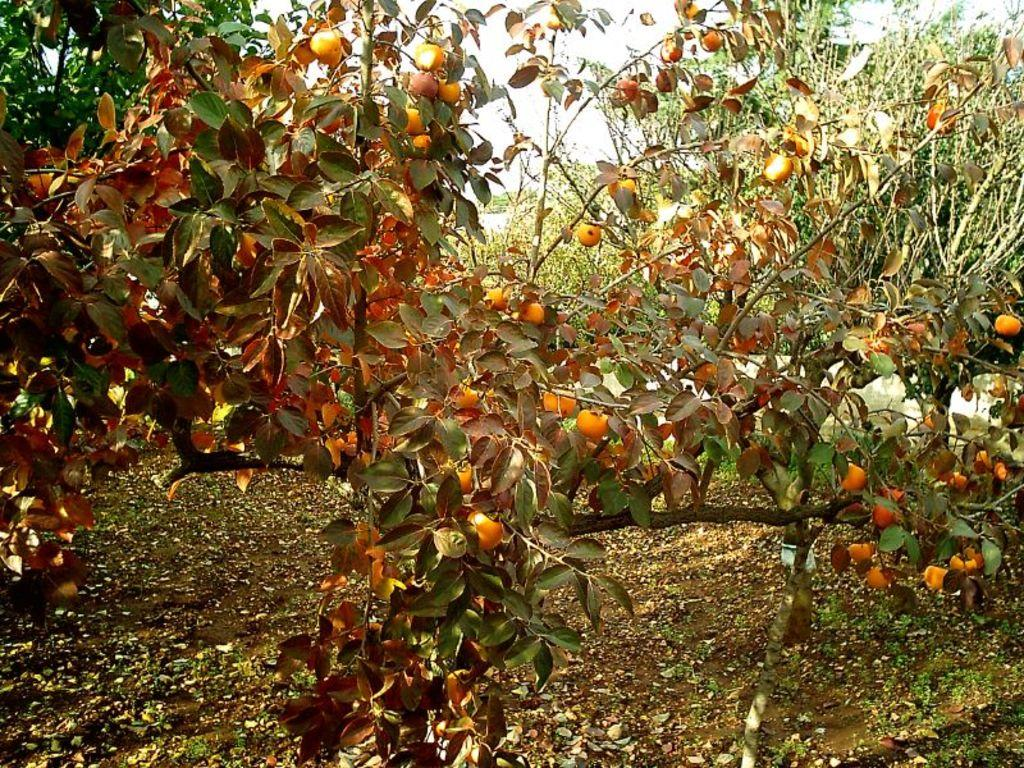What type of plants are in the image? There are trees with fruits in the image. What can be seen in the background of the image? The sky is visible in the background of the image. What type of oatmeal is being served in the image? There is no oatmeal present in the image; it features trees with fruits. Can you see any veins on the leaves of the trees in the image? The image does not show the leaves of the trees in enough detail to observe veins. How many lizards are visible in the image? There are no lizards present in the image; it features trees with fruits and a visible sky. 